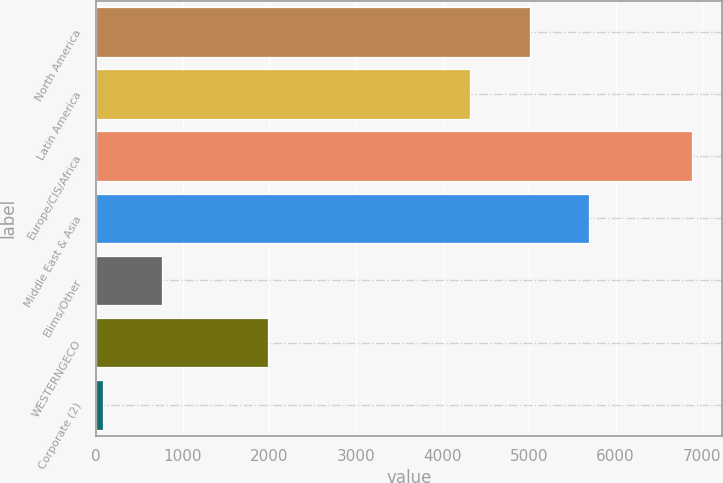Convert chart. <chart><loc_0><loc_0><loc_500><loc_500><bar_chart><fcel>North America<fcel>Latin America<fcel>Europe/CIS/Africa<fcel>Middle East & Asia<fcel>Elims/Other<fcel>WESTERNGECO<fcel>Corporate (2)<nl><fcel>5010<fcel>4321<fcel>6882<fcel>5690<fcel>762<fcel>1987<fcel>82<nl></chart> 